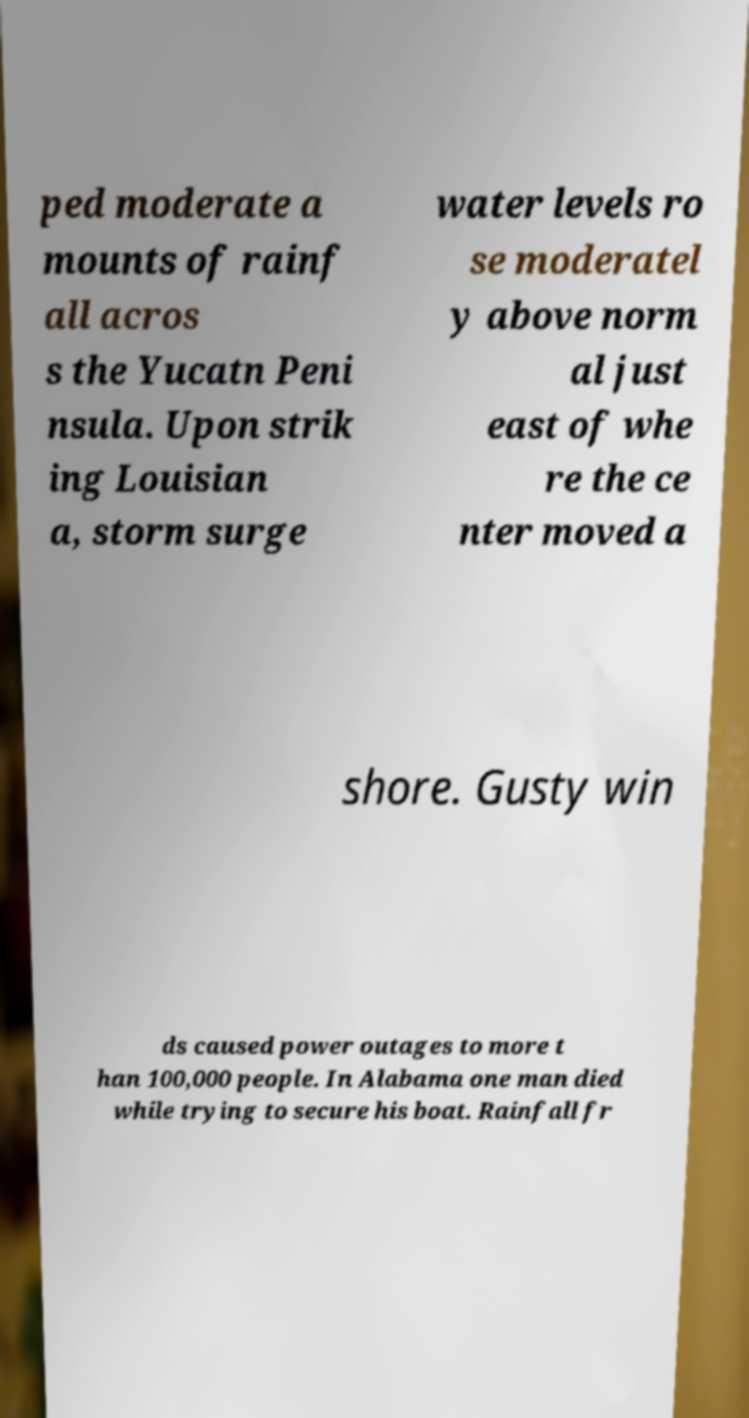Can you accurately transcribe the text from the provided image for me? ped moderate a mounts of rainf all acros s the Yucatn Peni nsula. Upon strik ing Louisian a, storm surge water levels ro se moderatel y above norm al just east of whe re the ce nter moved a shore. Gusty win ds caused power outages to more t han 100,000 people. In Alabama one man died while trying to secure his boat. Rainfall fr 